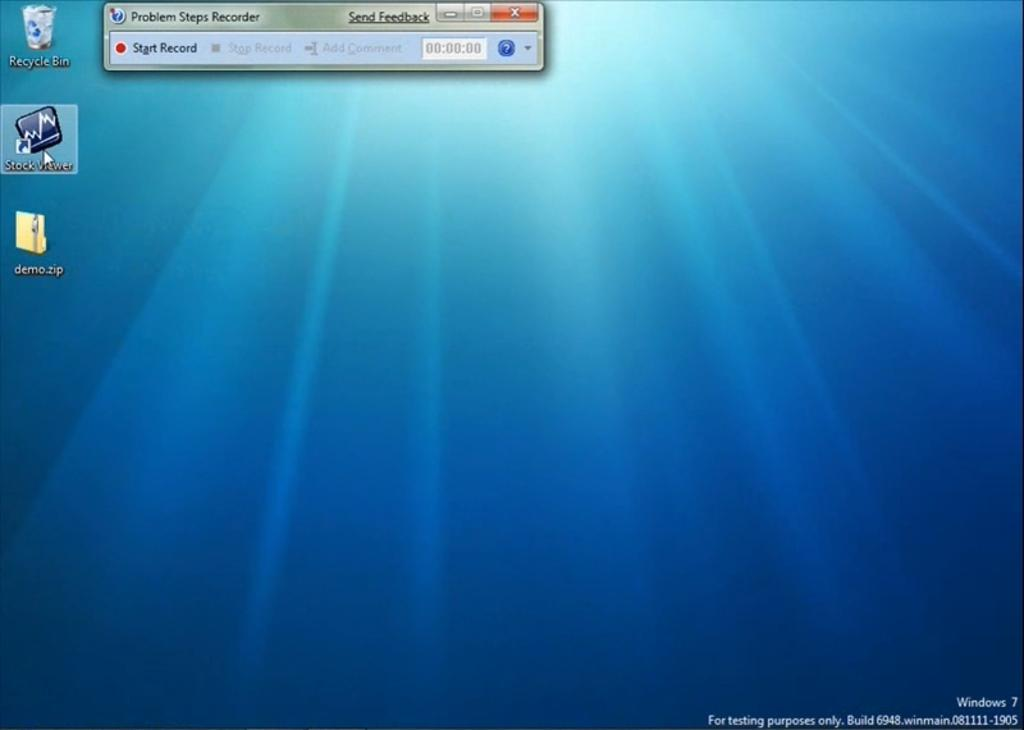<image>
Relay a brief, clear account of the picture shown. A pop up message on a computer screen with Problem Steps Recorder in its title. 